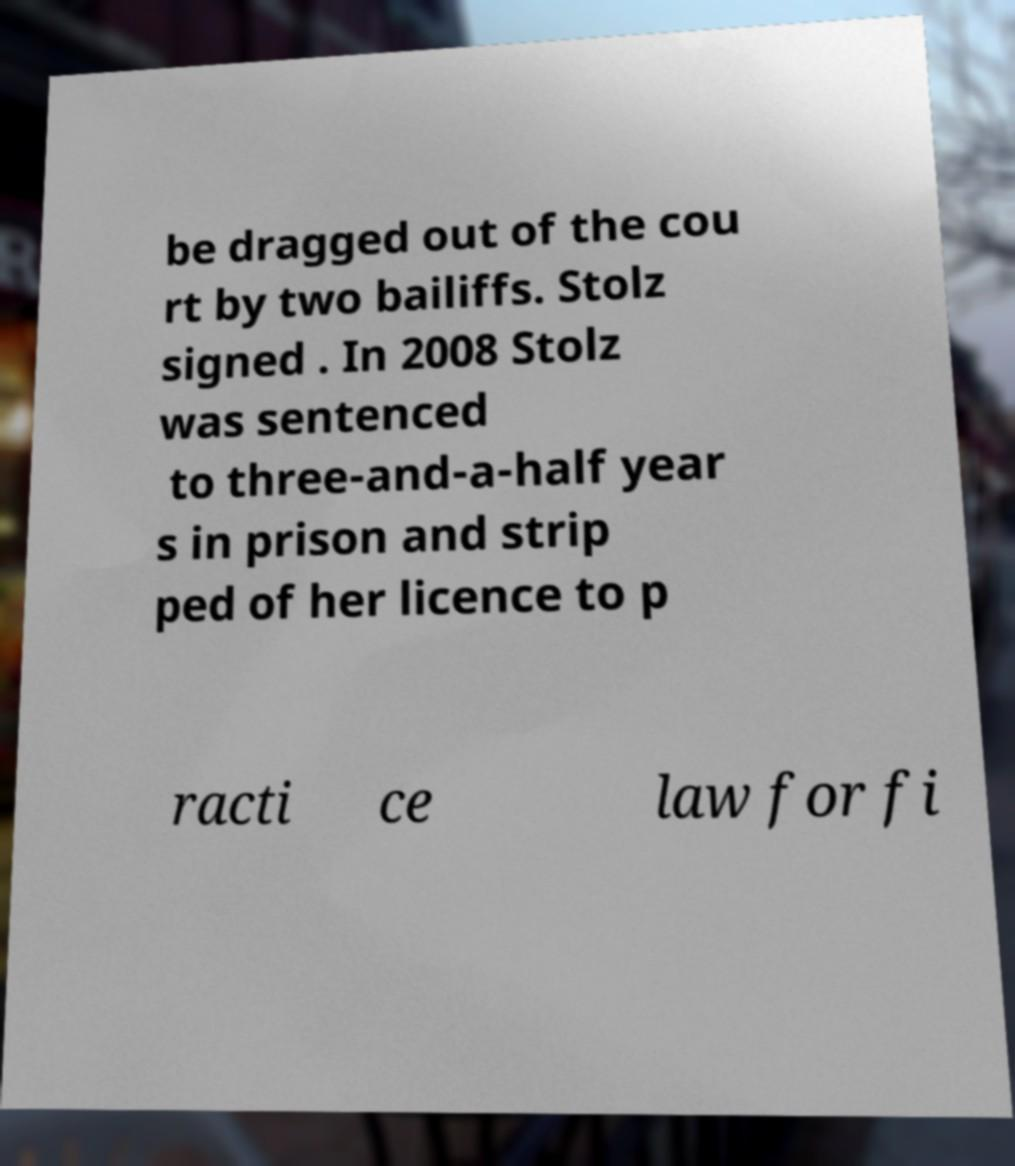Can you accurately transcribe the text from the provided image for me? be dragged out of the cou rt by two bailiffs. Stolz signed . In 2008 Stolz was sentenced to three-and-a-half year s in prison and strip ped of her licence to p racti ce law for fi 